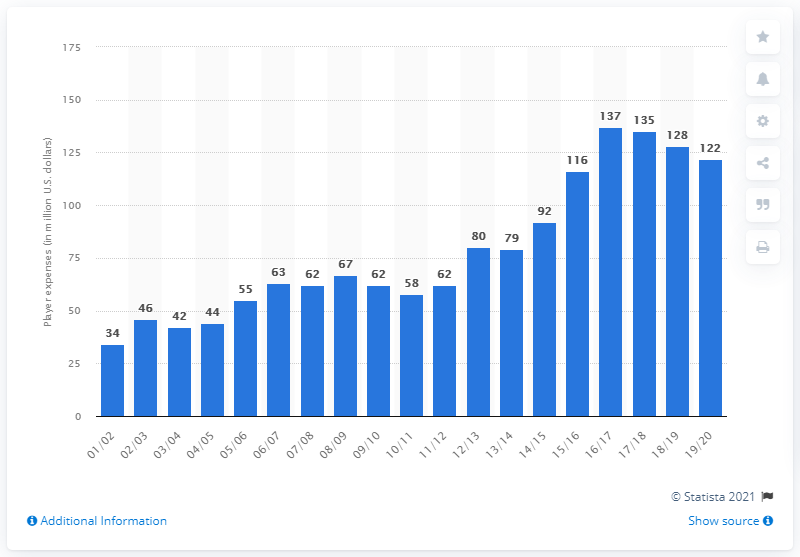Outline some significant characteristics in this image. In the 2019/2020 season, the player salary for the Los Angeles Clippers was 122. 